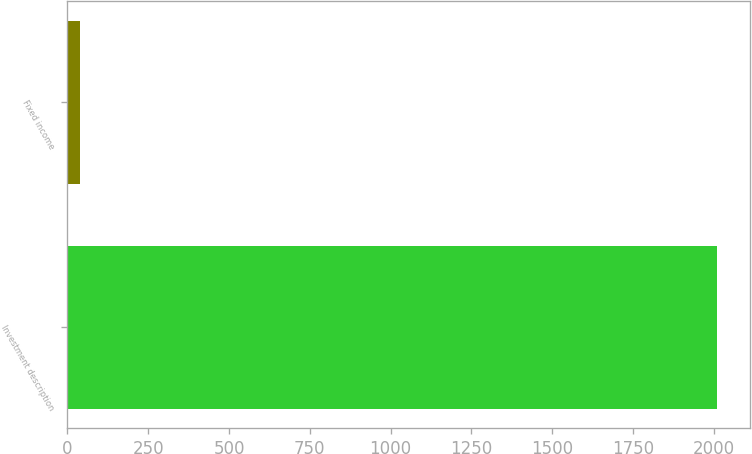Convert chart. <chart><loc_0><loc_0><loc_500><loc_500><bar_chart><fcel>Investment description<fcel>Fixed income<nl><fcel>2010<fcel>40<nl></chart> 